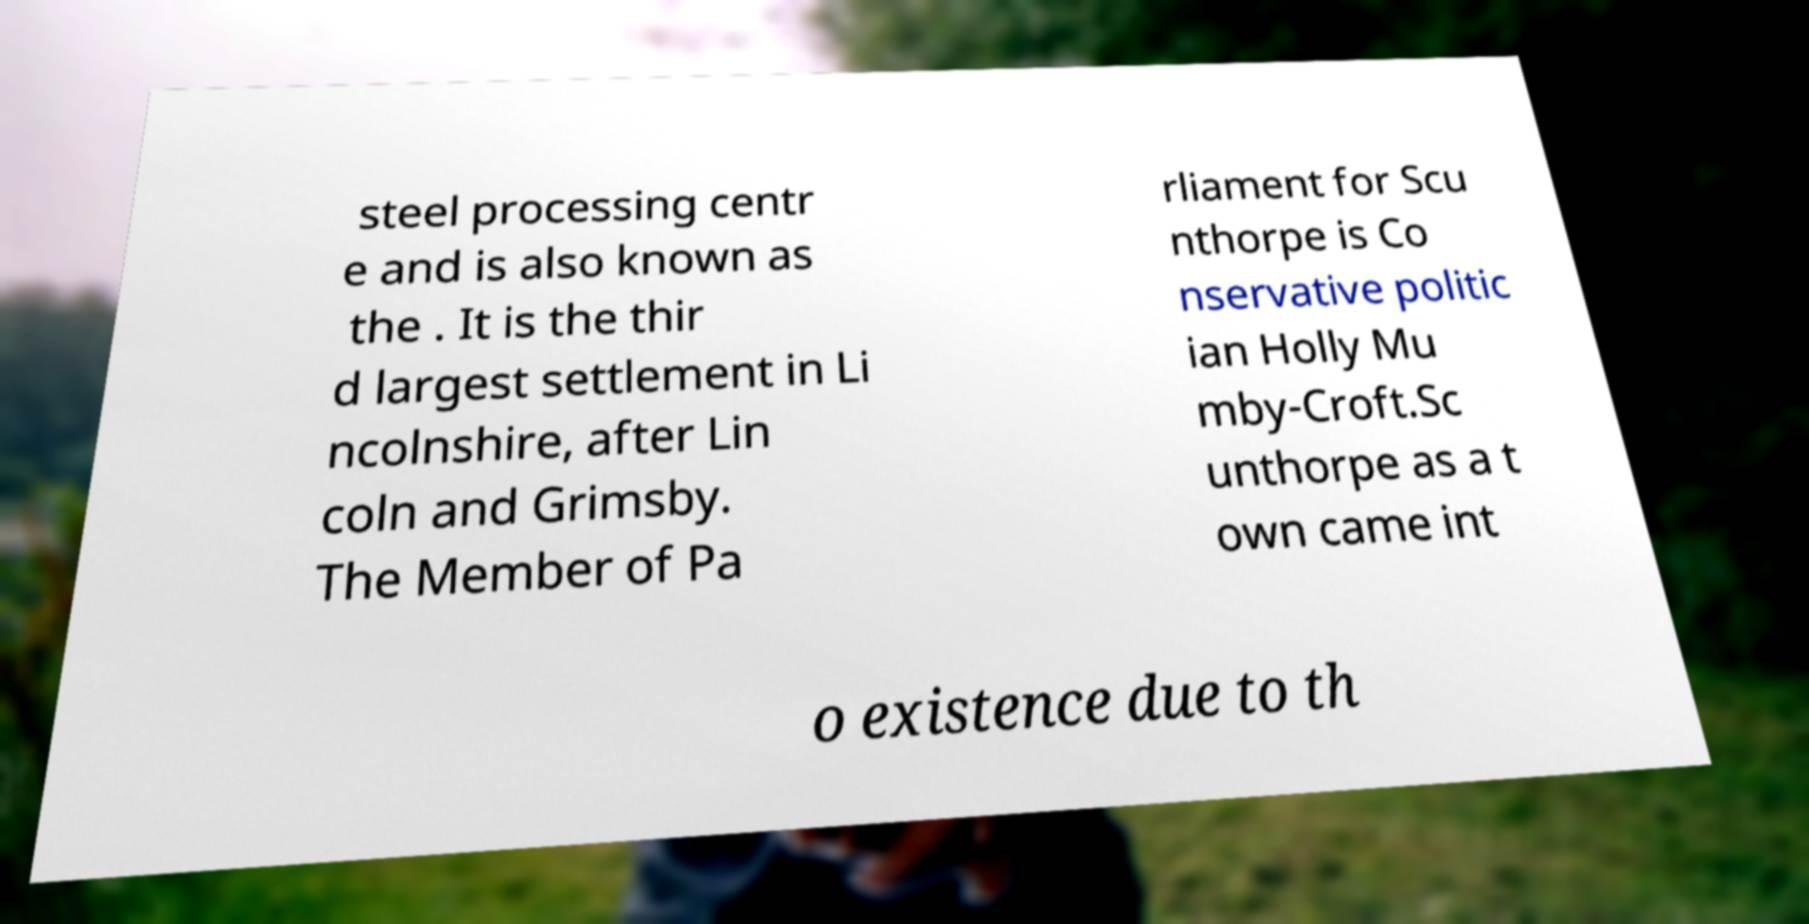What messages or text are displayed in this image? I need them in a readable, typed format. steel processing centr e and is also known as the . It is the thir d largest settlement in Li ncolnshire, after Lin coln and Grimsby. The Member of Pa rliament for Scu nthorpe is Co nservative politic ian Holly Mu mby-Croft.Sc unthorpe as a t own came int o existence due to th 